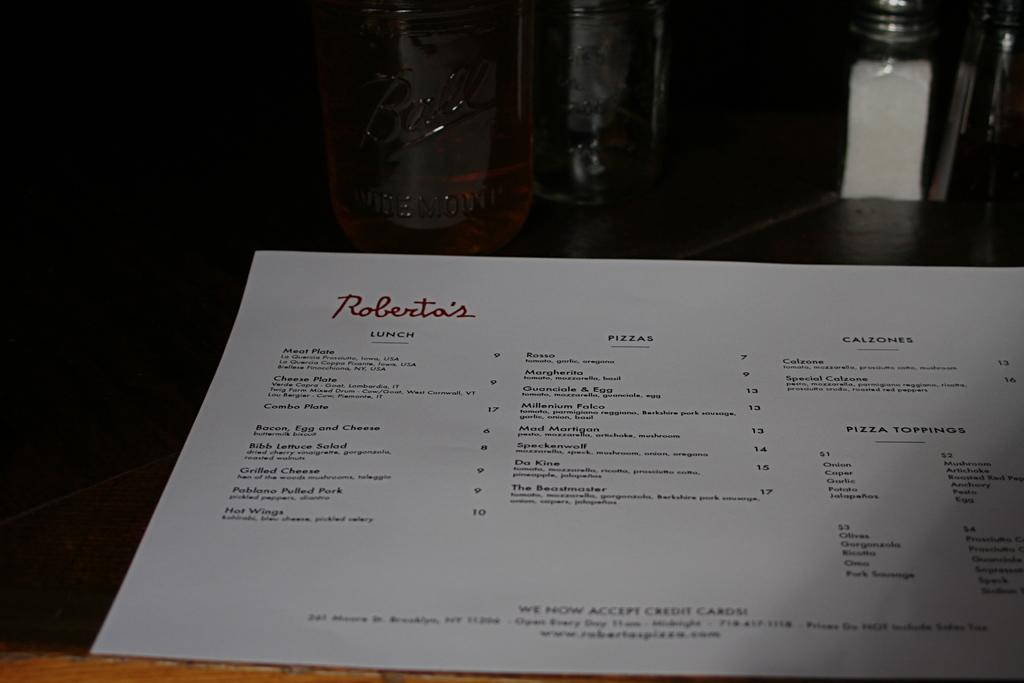<image>
Present a compact description of the photo's key features. A paper version of a food menu from Robertas 